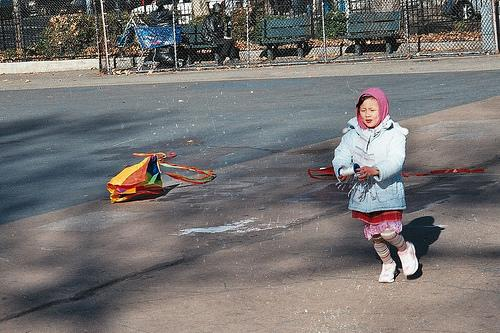What is the state of the kite in the image? The kite is red and yellow and has crashed onto the ground close to the girl who's trying to fly it. Tell me about the person and their attire in the image. The person is a girl wearing a light blue winter coat, a pink hood, striped multicolor stockings, and white shoes. She's playing in the park with a kite. What is the color and status of the girl's jacket and hood? The girl is wearing a light blue winter coat and a pink hood pulled over her head. What can be seen in the girl's hands? The girl is holding a spool of white twine in her hands, which is connected to the kite lying on the ground. What is happening with the benches and the fence in the scene? The green wooden benches are behind the tall metal fence which is located behind the girl who is out playing with a kite. How many benches are positioned in the scene and what color are they? There are three green wooden benches positioned behind the tall metal fence in the image. What unique features of the girl's attire stand out? The girl has a pink hood and wears striped multicolor stockings with a pair of white child-sized sneakers. Identify the nearby objects related to the main subject in the image. There are dried leaves on the ground, a tall metal fence, green wooden benches, and a blue shopping cart near the girl who's playing with a kite. Describe any observed shadows in the image. The girl casts a short shadow on the road, and there are black shadows visible on the street in another part of the picture. Describe the scene where the girl is standing. The girl is standing on a grey road, casting a short shadow, with dried leaves on the ground nearby; there's a tall metal fence behind her with green wooden benches and a blue shopping cart. Is the girl in the image wearing a red hoodie? The girl is actually wearing a pink hoodie, not a red one. What color is the girl's hood in her jacket? Pink Is the kite's primary color purple? The kite is actually red and yellow, not purple. Is the kite on the ground or flying in the sky? On the ground Which of these describes the fence in the picture: tall metal fence, short wooden fence, or tall wooden fence? Tall metal fence Is the road's color blue in the image? The road is actually grey, not blue. Which of these objects can be found behind the fence: wooden green benches, blue shopping cart, or dried leaves on the ground? Wooden green benches Does the girl have plain black socks on? The girl is actually wearing striped multicolor socks, not plain black ones. Explain the kite's position in relation to the girl. The kite is close to the ground near the girl. Are there two red benches behind the fence in the image? There are three green wooden benches, not red ones. What is the girl's main activity in the scene? Trying to fly a kite Describe the girl's appearance. The girl is wearing a blue winter coat, a pink hood, striped leggings, and child-sized sneakers. What is the color and pattern of the socks the girl is wearing? Brightly colored and striped Identify the object the girl is holding. Spool of twine Is there a green shopping cart in the picture? The shopping cart is actually blue, not green. 